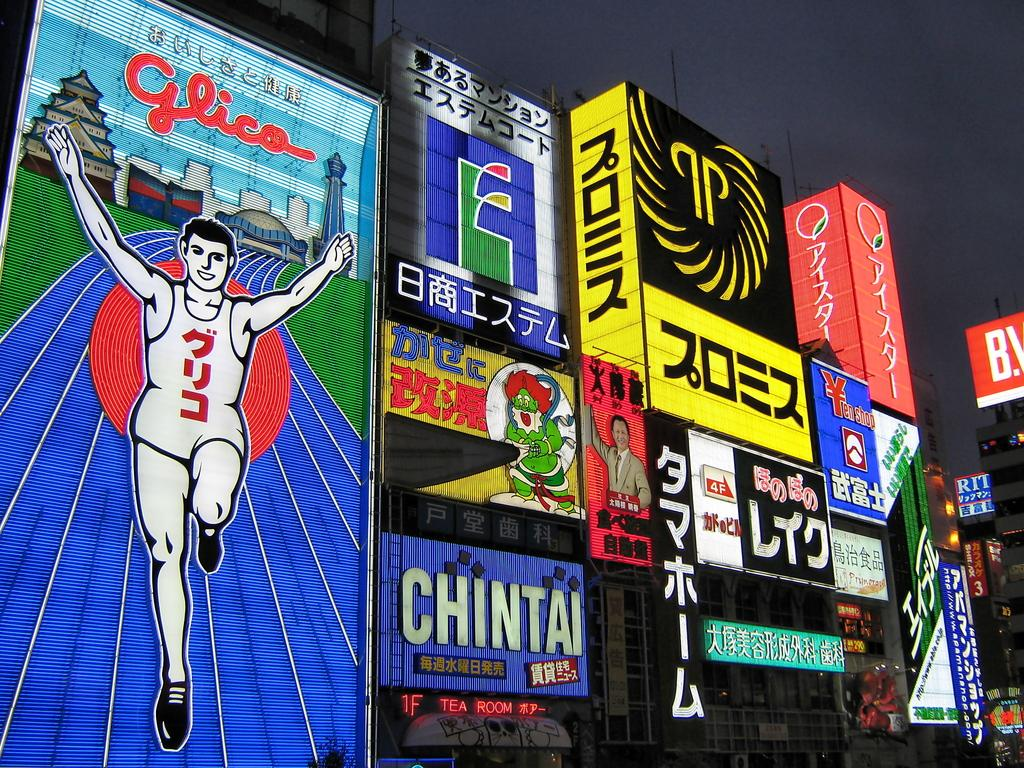<image>
Present a compact description of the photo's key features. a Glico sign is lit up with many others 